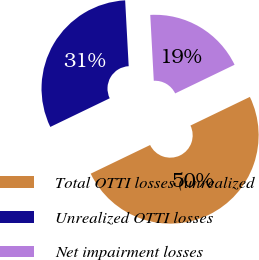Convert chart. <chart><loc_0><loc_0><loc_500><loc_500><pie_chart><fcel>Total OTTI losses (unrealized<fcel>Unrealized OTTI losses<fcel>Net impairment losses<nl><fcel>50.0%<fcel>31.3%<fcel>18.7%<nl></chart> 